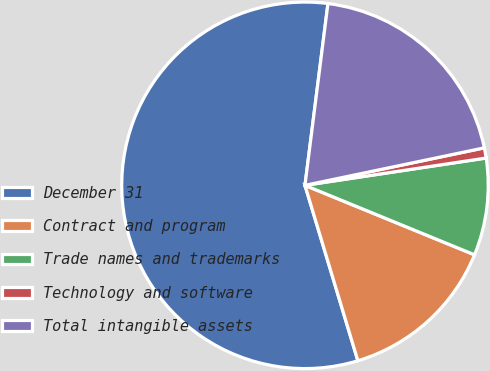<chart> <loc_0><loc_0><loc_500><loc_500><pie_chart><fcel>December 31<fcel>Contract and program<fcel>Trade names and trademarks<fcel>Technology and software<fcel>Total intangible assets<nl><fcel>56.67%<fcel>14.15%<fcel>8.57%<fcel>0.9%<fcel>19.72%<nl></chart> 